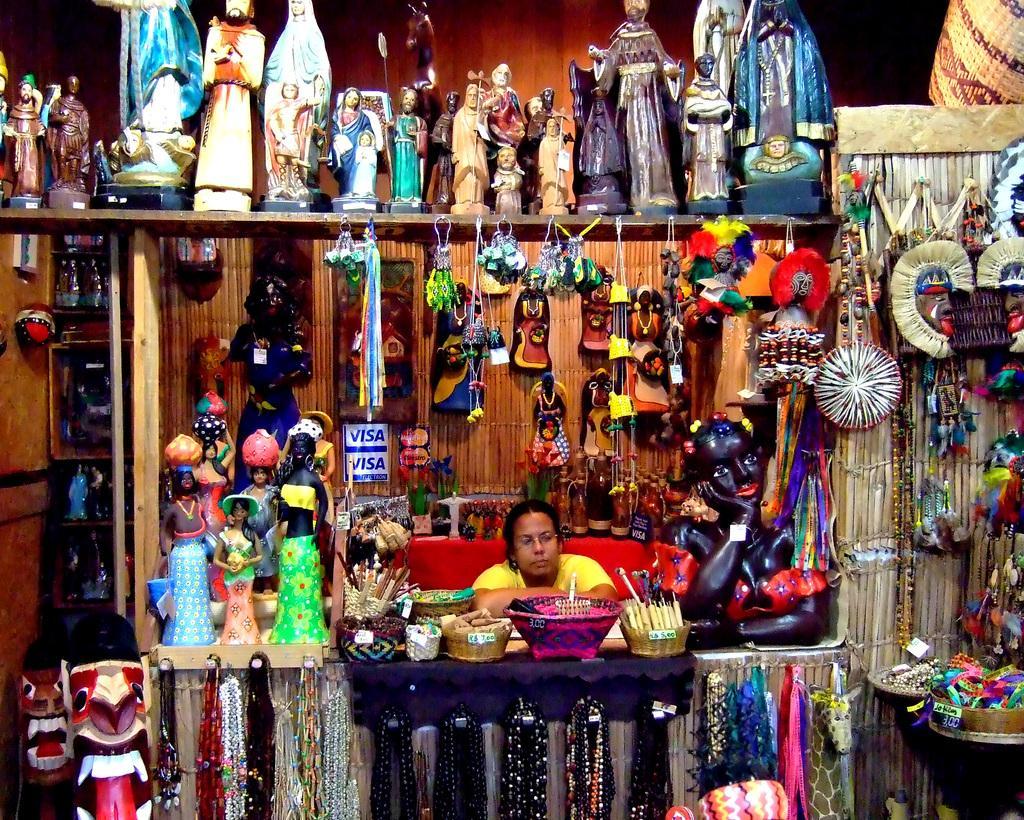How would you summarize this image in a sentence or two? In this image I can see a person sitting in the center, wearing a yellow t shirt. There are many objects surrounded by her. There are sculptures at the top and hangings at the bottom of the image. 